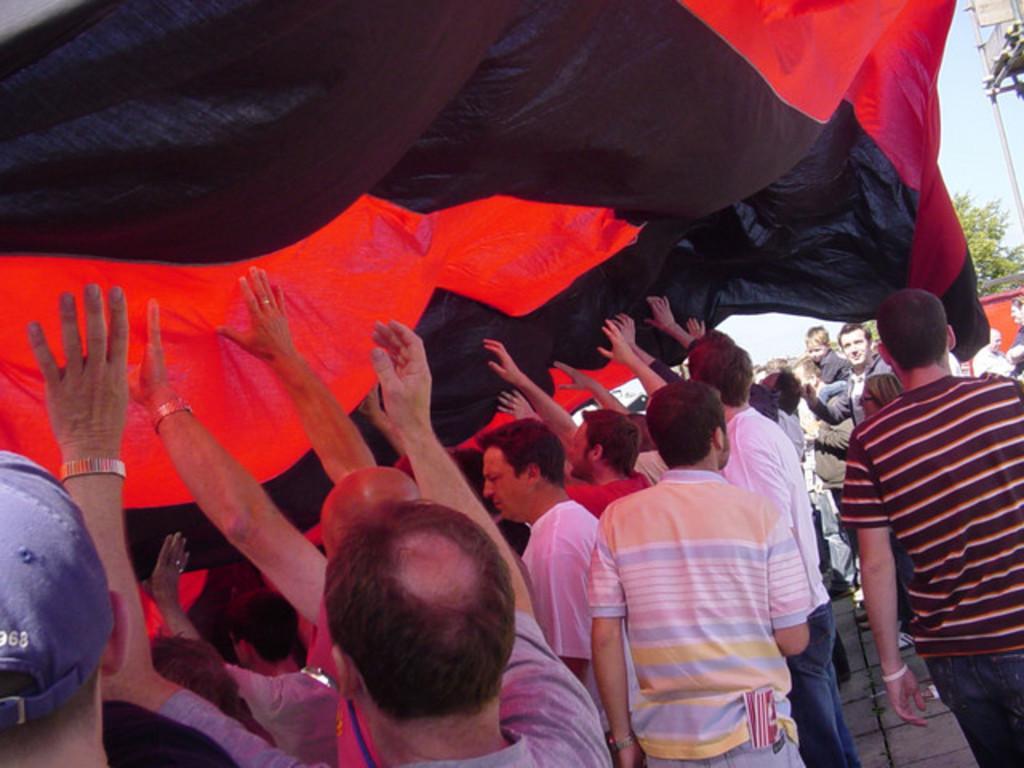In one or two sentences, can you explain what this image depicts? In this image we can see many people. Also there are many people. Also there is a sheet. One person is wearing a cap. Some are wearing watches. In the background there is sky, tree. On the right side there is a pole. 